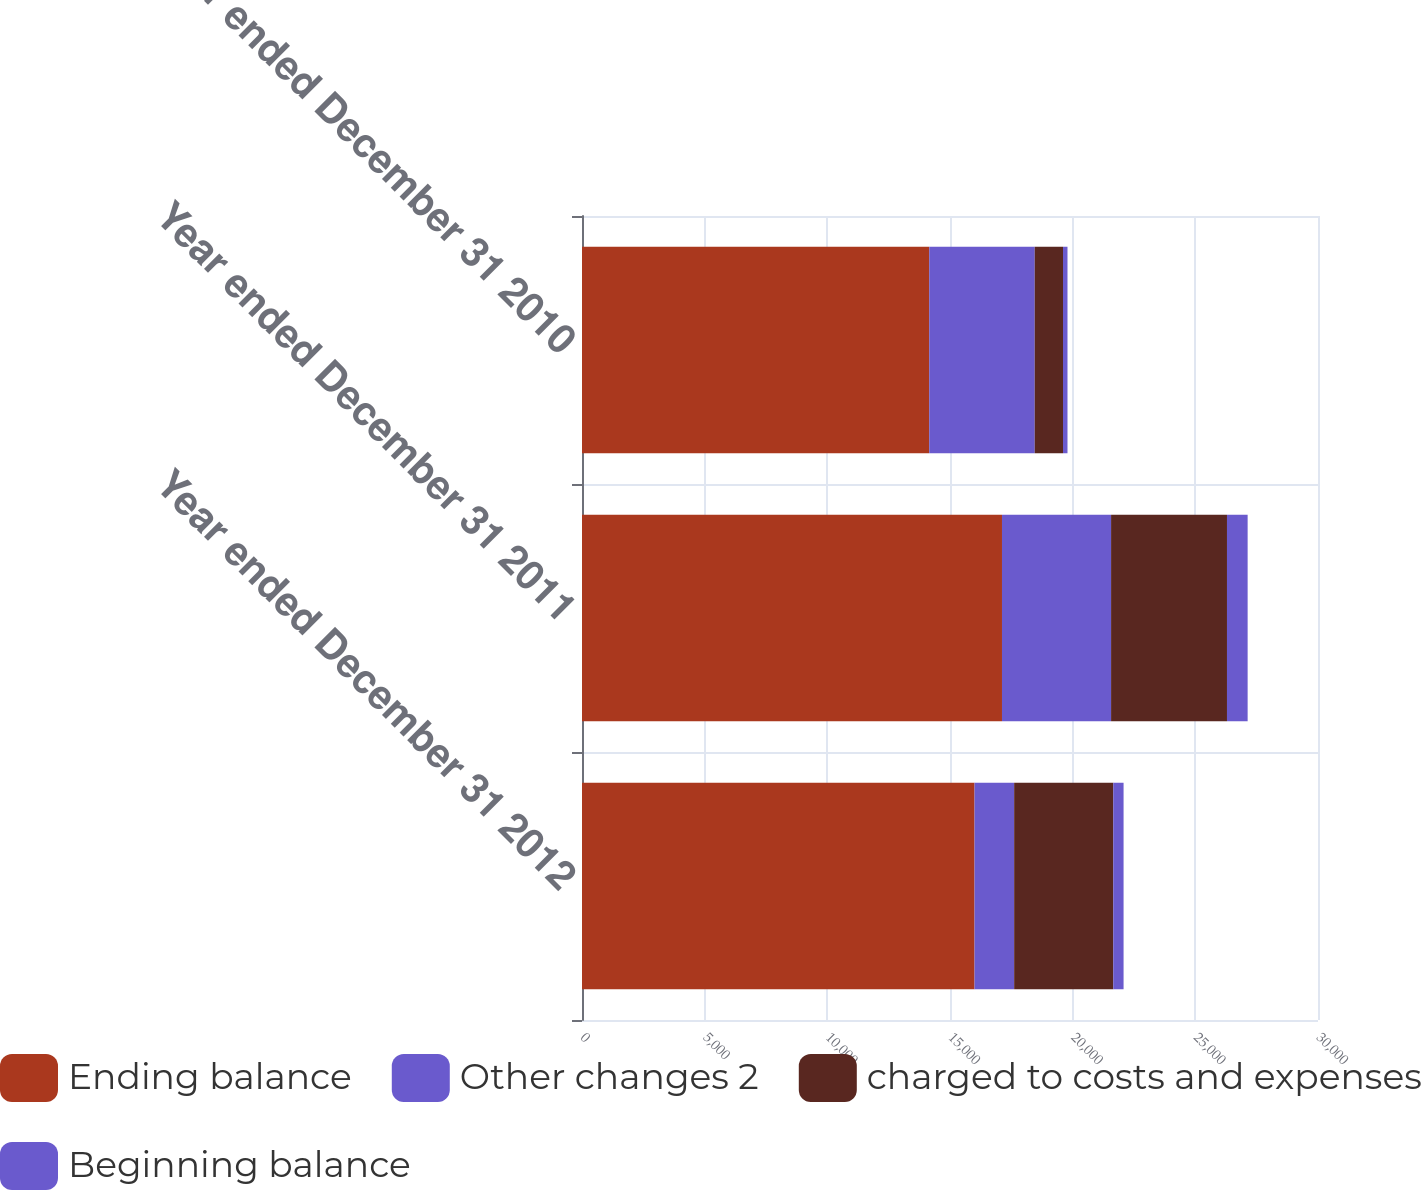<chart> <loc_0><loc_0><loc_500><loc_500><stacked_bar_chart><ecel><fcel>Year ended December 31 2012<fcel>Year ended December 31 2011<fcel>Year ended December 31 2010<nl><fcel>Ending balance<fcel>16000<fcel>17119<fcel>14154<nl><fcel>Other changes 2<fcel>1615<fcel>4447<fcel>4300<nl><fcel>charged to costs and expenses<fcel>4040<fcel>4724<fcel>1152<nl><fcel>Beginning balance<fcel>420<fcel>842<fcel>183<nl></chart> 